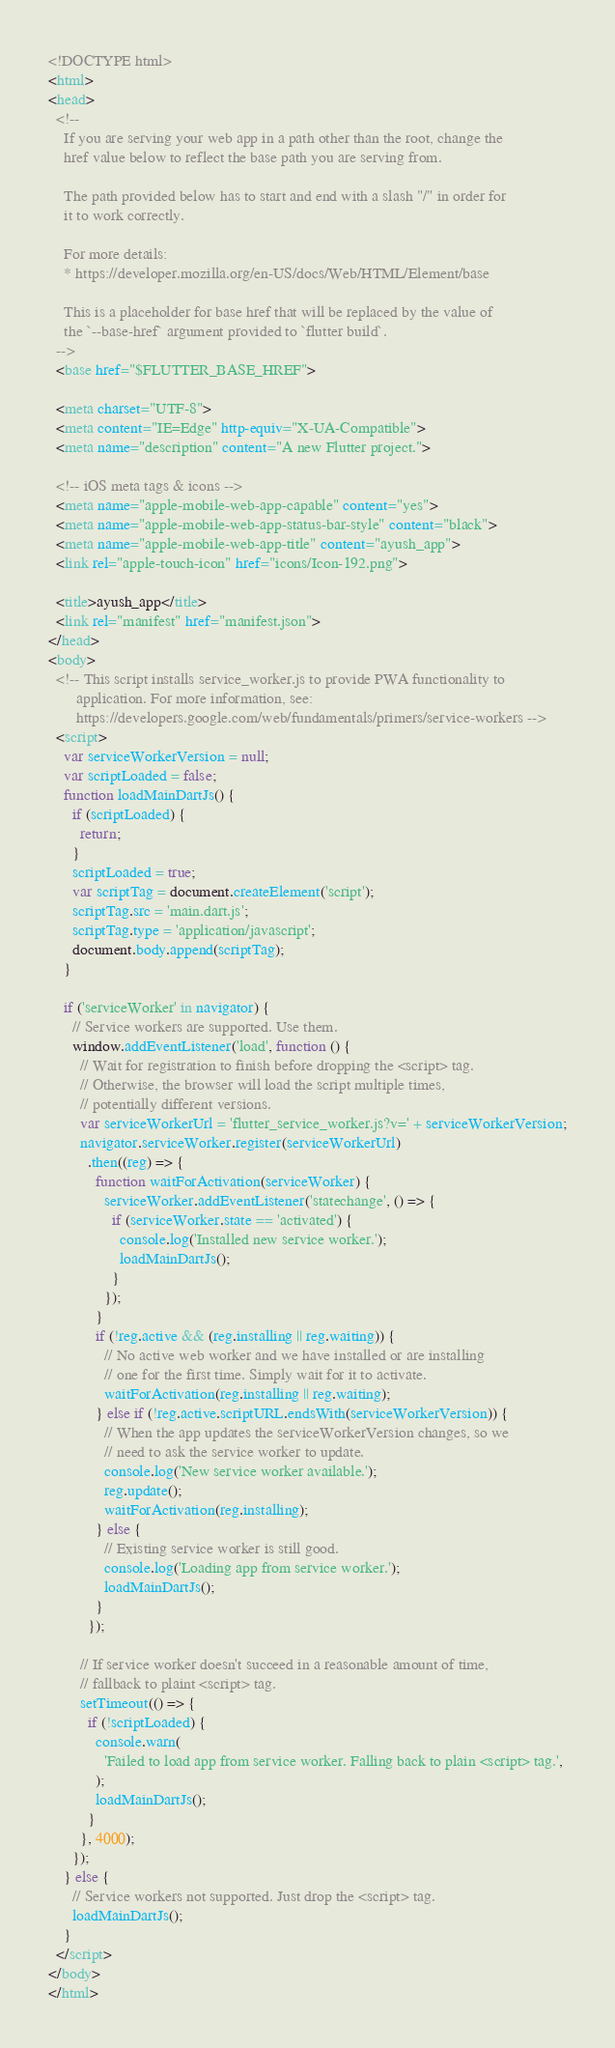Convert code to text. <code><loc_0><loc_0><loc_500><loc_500><_HTML_><!DOCTYPE html>
<html>
<head>
  <!--
    If you are serving your web app in a path other than the root, change the
    href value below to reflect the base path you are serving from.

    The path provided below has to start and end with a slash "/" in order for
    it to work correctly.

    For more details:
    * https://developer.mozilla.org/en-US/docs/Web/HTML/Element/base

    This is a placeholder for base href that will be replaced by the value of
    the `--base-href` argument provided to `flutter build`.
  -->
  <base href="$FLUTTER_BASE_HREF">

  <meta charset="UTF-8">
  <meta content="IE=Edge" http-equiv="X-UA-Compatible">
  <meta name="description" content="A new Flutter project.">

  <!-- iOS meta tags & icons -->
  <meta name="apple-mobile-web-app-capable" content="yes">
  <meta name="apple-mobile-web-app-status-bar-style" content="black">
  <meta name="apple-mobile-web-app-title" content="ayush_app">
  <link rel="apple-touch-icon" href="icons/Icon-192.png">

  <title>ayush_app</title>
  <link rel="manifest" href="manifest.json">
</head>
<body>
  <!-- This script installs service_worker.js to provide PWA functionality to
       application. For more information, see:
       https://developers.google.com/web/fundamentals/primers/service-workers -->
  <script>
    var serviceWorkerVersion = null;
    var scriptLoaded = false;
    function loadMainDartJs() {
      if (scriptLoaded) {
        return;
      }
      scriptLoaded = true;
      var scriptTag = document.createElement('script');
      scriptTag.src = 'main.dart.js';
      scriptTag.type = 'application/javascript';
      document.body.append(scriptTag);
    }

    if ('serviceWorker' in navigator) {
      // Service workers are supported. Use them.
      window.addEventListener('load', function () {
        // Wait for registration to finish before dropping the <script> tag.
        // Otherwise, the browser will load the script multiple times,
        // potentially different versions.
        var serviceWorkerUrl = 'flutter_service_worker.js?v=' + serviceWorkerVersion;
        navigator.serviceWorker.register(serviceWorkerUrl)
          .then((reg) => {
            function waitForActivation(serviceWorker) {
              serviceWorker.addEventListener('statechange', () => {
                if (serviceWorker.state == 'activated') {
                  console.log('Installed new service worker.');
                  loadMainDartJs();
                }
              });
            }
            if (!reg.active && (reg.installing || reg.waiting)) {
              // No active web worker and we have installed or are installing
              // one for the first time. Simply wait for it to activate.
              waitForActivation(reg.installing || reg.waiting);
            } else if (!reg.active.scriptURL.endsWith(serviceWorkerVersion)) {
              // When the app updates the serviceWorkerVersion changes, so we
              // need to ask the service worker to update.
              console.log('New service worker available.');
              reg.update();
              waitForActivation(reg.installing);
            } else {
              // Existing service worker is still good.
              console.log('Loading app from service worker.');
              loadMainDartJs();
            }
          });

        // If service worker doesn't succeed in a reasonable amount of time,
        // fallback to plaint <script> tag.
        setTimeout(() => {
          if (!scriptLoaded) {
            console.warn(
              'Failed to load app from service worker. Falling back to plain <script> tag.',
            );
            loadMainDartJs();
          }
        }, 4000);
      });
    } else {
      // Service workers not supported. Just drop the <script> tag.
      loadMainDartJs();
    }
  </script>
</body>
</html>
</code> 